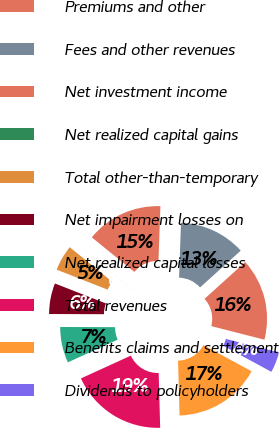<chart> <loc_0><loc_0><loc_500><loc_500><pie_chart><fcel>Premiums and other<fcel>Fees and other revenues<fcel>Net investment income<fcel>Net realized capital gains<fcel>Total other-than-temporary<fcel>Net impairment losses on<fcel>Net realized capital losses<fcel>Total revenues<fcel>Benefits claims and settlement<fcel>Dividends to policyholders<nl><fcel>15.68%<fcel>12.74%<fcel>14.7%<fcel>0.01%<fcel>4.91%<fcel>5.89%<fcel>6.87%<fcel>18.62%<fcel>16.66%<fcel>3.93%<nl></chart> 